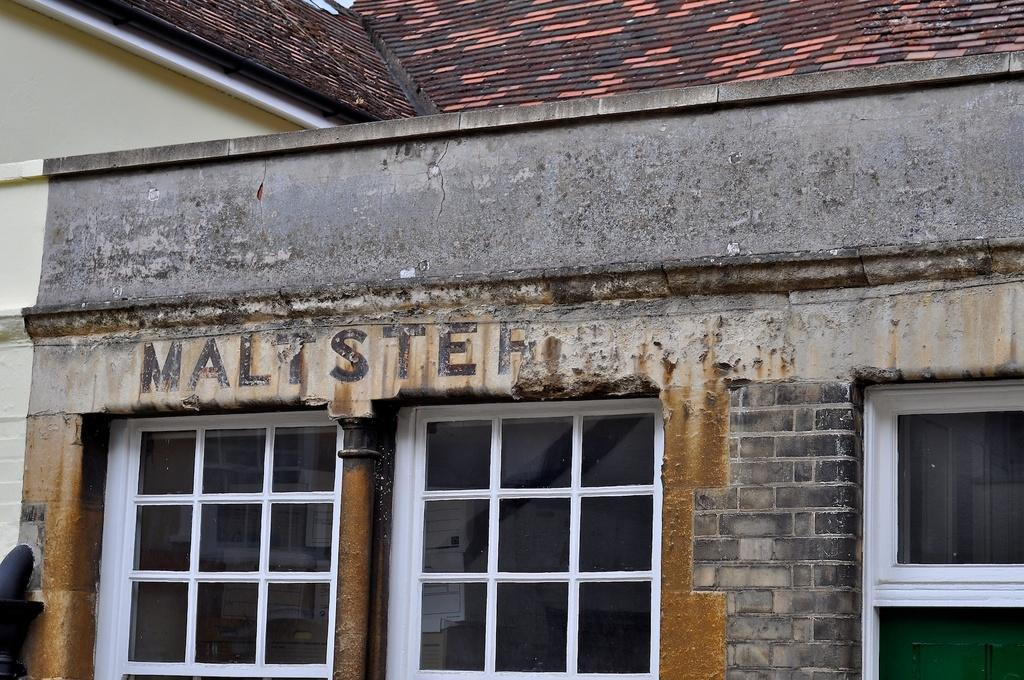What type of structure is present in the image? There is a building in the image. What can be seen attached to the building? There are pipes and windows visible in the image. Is there any text or writing present in the image? Yes, there is text or writing visible in the image. What type of toy can be seen flying in the image? There is no toy present in the image, and therefore no such activity can be observed. 